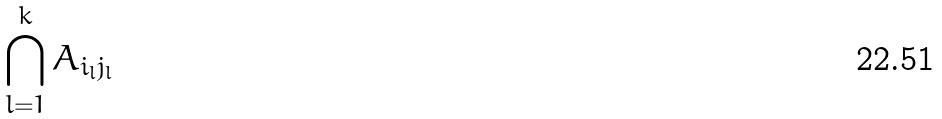Convert formula to latex. <formula><loc_0><loc_0><loc_500><loc_500>\bigcap _ { l = 1 } ^ { k } A _ { i _ { l } j _ { l } }</formula> 